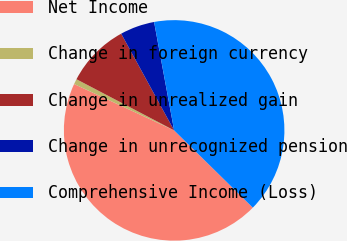<chart> <loc_0><loc_0><loc_500><loc_500><pie_chart><fcel>Net Income<fcel>Change in foreign currency<fcel>Change in unrealized gain<fcel>Change in unrecognized pension<fcel>Comprehensive Income (Loss)<nl><fcel>44.56%<fcel>0.77%<fcel>9.35%<fcel>5.06%<fcel>40.27%<nl></chart> 